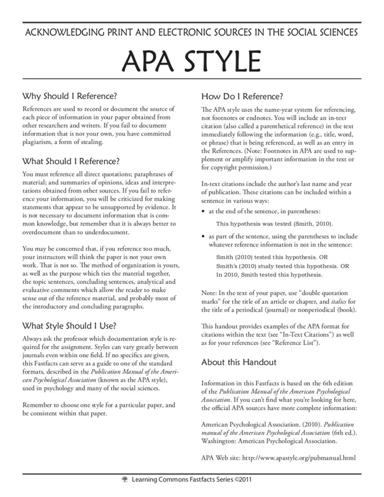What are the specifics of citing a book in APA style as mentioned in the image? For citing a book in APA style, you need the author's last name and the year of publication in the in-text citation. The reference list entry must include the author's name, year, book title in italics, and the publishing details. 